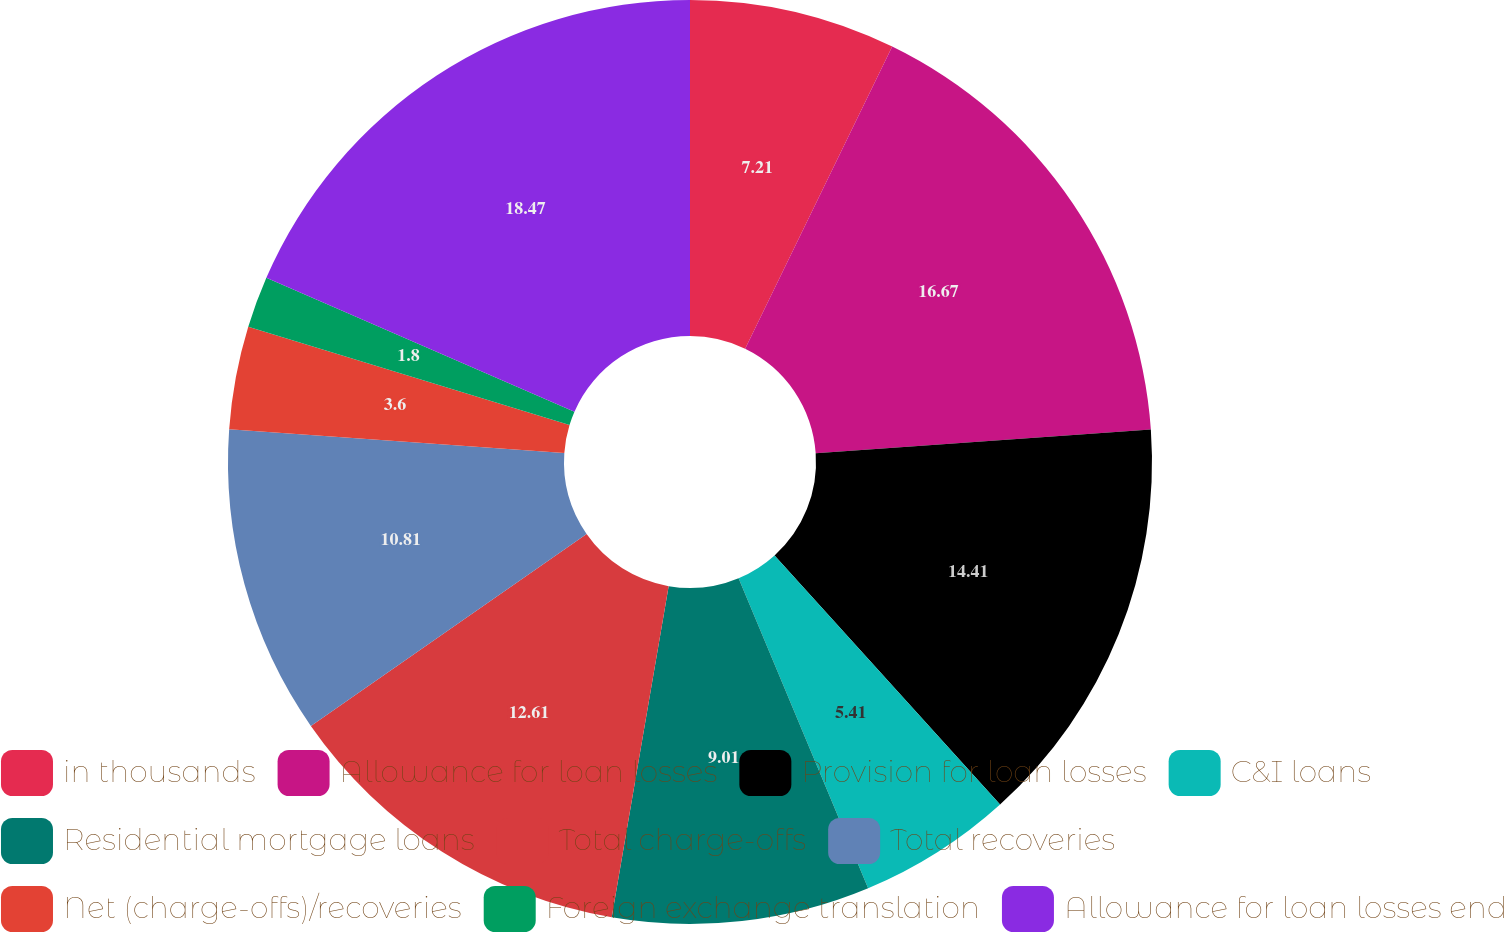Convert chart to OTSL. <chart><loc_0><loc_0><loc_500><loc_500><pie_chart><fcel>in thousands<fcel>Allowance for loan losses<fcel>Provision for loan losses<fcel>C&I loans<fcel>Residential mortgage loans<fcel>Total charge-offs<fcel>Total recoveries<fcel>Net (charge-offs)/recoveries<fcel>Foreign exchange translation<fcel>Allowance for loan losses end<nl><fcel>7.21%<fcel>16.67%<fcel>14.41%<fcel>5.41%<fcel>9.01%<fcel>12.61%<fcel>10.81%<fcel>3.6%<fcel>1.8%<fcel>18.47%<nl></chart> 